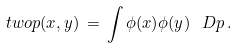Convert formula to latex. <formula><loc_0><loc_0><loc_500><loc_500>\ t w o p ( x , y ) \, = \, \int \phi ( x ) \phi ( y ) \, \ D p \, .</formula> 